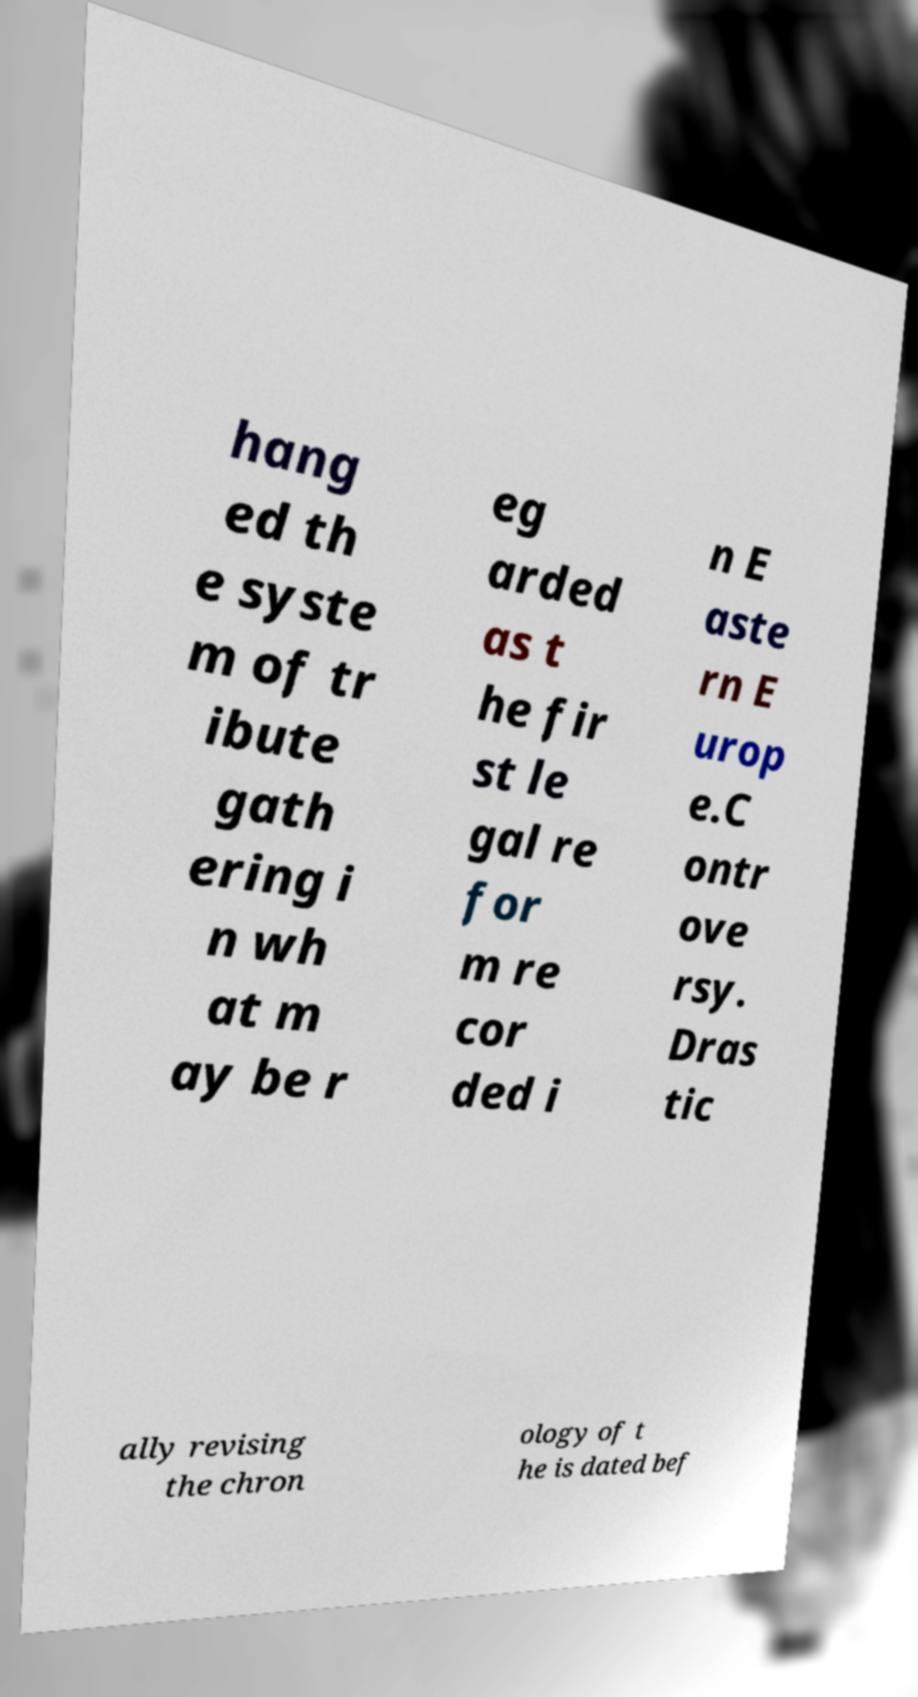For documentation purposes, I need the text within this image transcribed. Could you provide that? hang ed th e syste m of tr ibute gath ering i n wh at m ay be r eg arded as t he fir st le gal re for m re cor ded i n E aste rn E urop e.C ontr ove rsy. Dras tic ally revising the chron ology of t he is dated bef 